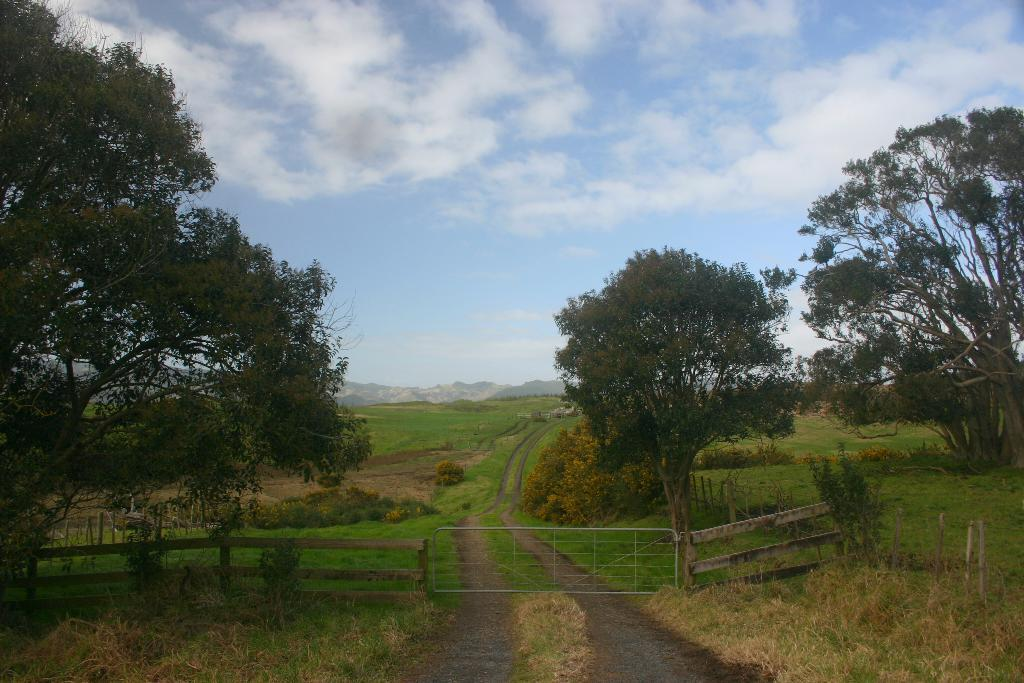What type of barrier is in the image? There is a wooden fence in the image. Is there an entrance in the wooden fence? Yes, there is a gate in the image. What type of vegetation is present in the image? Grass, plants, and trees are visible in the image. What type of landscape feature is visible in the image? Hills are visible in the image. What is visible in the background of the image? The sky is visible in the background of the image. Where is the throne located in the image? There is no throne present in the image. What type of nerves can be seen in the image? There are no nerves visible in the image, as it is a photograph of a landscape, not a biological or medical image. 